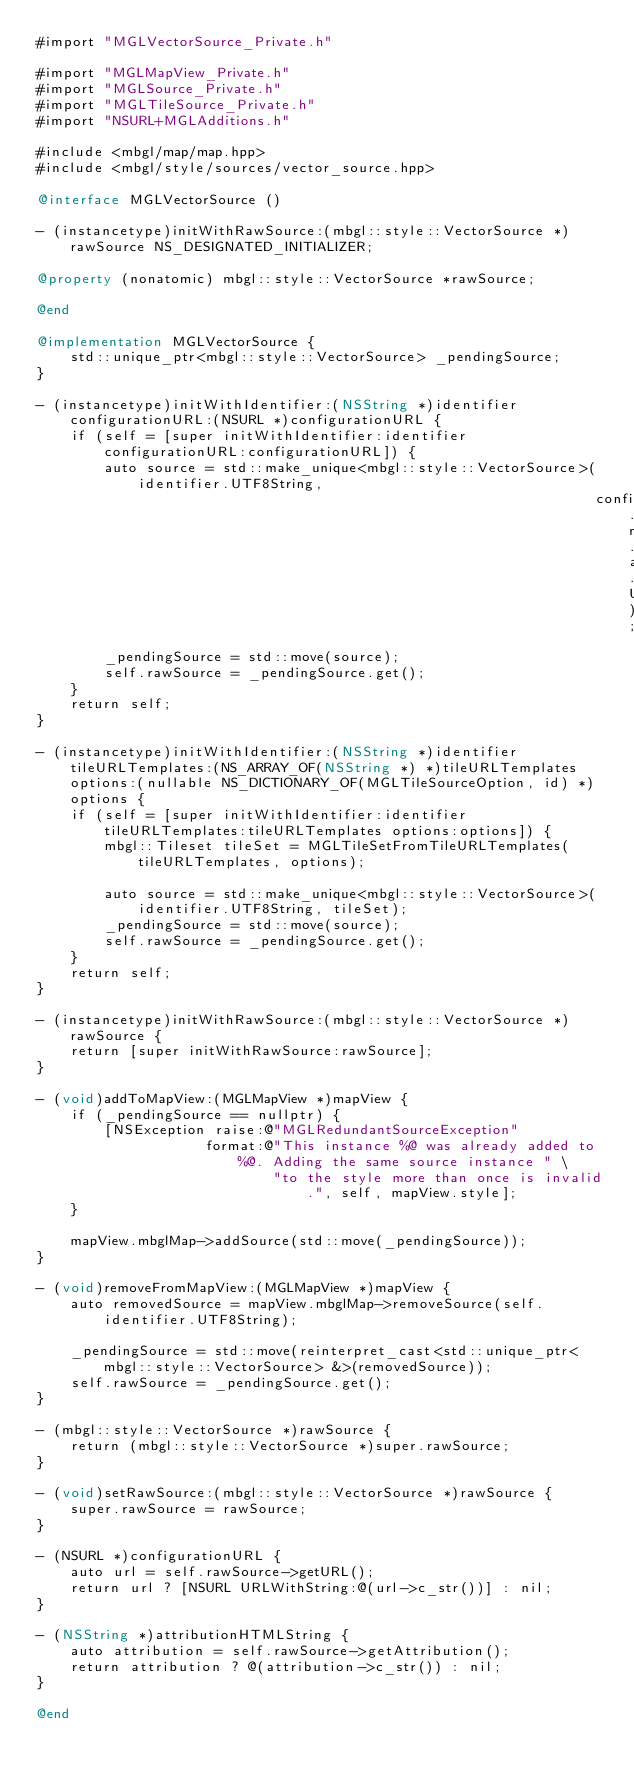Convert code to text. <code><loc_0><loc_0><loc_500><loc_500><_ObjectiveC_>#import "MGLVectorSource_Private.h"

#import "MGLMapView_Private.h"
#import "MGLSource_Private.h"
#import "MGLTileSource_Private.h"
#import "NSURL+MGLAdditions.h"

#include <mbgl/map/map.hpp>
#include <mbgl/style/sources/vector_source.hpp>

@interface MGLVectorSource ()

- (instancetype)initWithRawSource:(mbgl::style::VectorSource *)rawSource NS_DESIGNATED_INITIALIZER;

@property (nonatomic) mbgl::style::VectorSource *rawSource;

@end

@implementation MGLVectorSource {
    std::unique_ptr<mbgl::style::VectorSource> _pendingSource;
}

- (instancetype)initWithIdentifier:(NSString *)identifier configurationURL:(NSURL *)configurationURL {
    if (self = [super initWithIdentifier:identifier configurationURL:configurationURL]) {
        auto source = std::make_unique<mbgl::style::VectorSource>(identifier.UTF8String,
                                                                  configurationURL.mgl_URLByStandardizingScheme.absoluteString.UTF8String);
        _pendingSource = std::move(source);
        self.rawSource = _pendingSource.get();
    }
    return self;
}

- (instancetype)initWithIdentifier:(NSString *)identifier tileURLTemplates:(NS_ARRAY_OF(NSString *) *)tileURLTemplates options:(nullable NS_DICTIONARY_OF(MGLTileSourceOption, id) *)options {
    if (self = [super initWithIdentifier:identifier tileURLTemplates:tileURLTemplates options:options]) {
        mbgl::Tileset tileSet = MGLTileSetFromTileURLTemplates(tileURLTemplates, options);

        auto source = std::make_unique<mbgl::style::VectorSource>(identifier.UTF8String, tileSet);
        _pendingSource = std::move(source);
        self.rawSource = _pendingSource.get();
    }
    return self;
}

- (instancetype)initWithRawSource:(mbgl::style::VectorSource *)rawSource {
    return [super initWithRawSource:rawSource];
}

- (void)addToMapView:(MGLMapView *)mapView {
    if (_pendingSource == nullptr) {
        [NSException raise:@"MGLRedundantSourceException"
                    format:@"This instance %@ was already added to %@. Adding the same source instance " \
                            "to the style more than once is invalid.", self, mapView.style];
    }

    mapView.mbglMap->addSource(std::move(_pendingSource));
}

- (void)removeFromMapView:(MGLMapView *)mapView {
    auto removedSource = mapView.mbglMap->removeSource(self.identifier.UTF8String);

    _pendingSource = std::move(reinterpret_cast<std::unique_ptr<mbgl::style::VectorSource> &>(removedSource));
    self.rawSource = _pendingSource.get();
}

- (mbgl::style::VectorSource *)rawSource {
    return (mbgl::style::VectorSource *)super.rawSource;
}

- (void)setRawSource:(mbgl::style::VectorSource *)rawSource {
    super.rawSource = rawSource;
}

- (NSURL *)configurationURL {
    auto url = self.rawSource->getURL();
    return url ? [NSURL URLWithString:@(url->c_str())] : nil;
}

- (NSString *)attributionHTMLString {
    auto attribution = self.rawSource->getAttribution();
    return attribution ? @(attribution->c_str()) : nil;
}

@end
</code> 